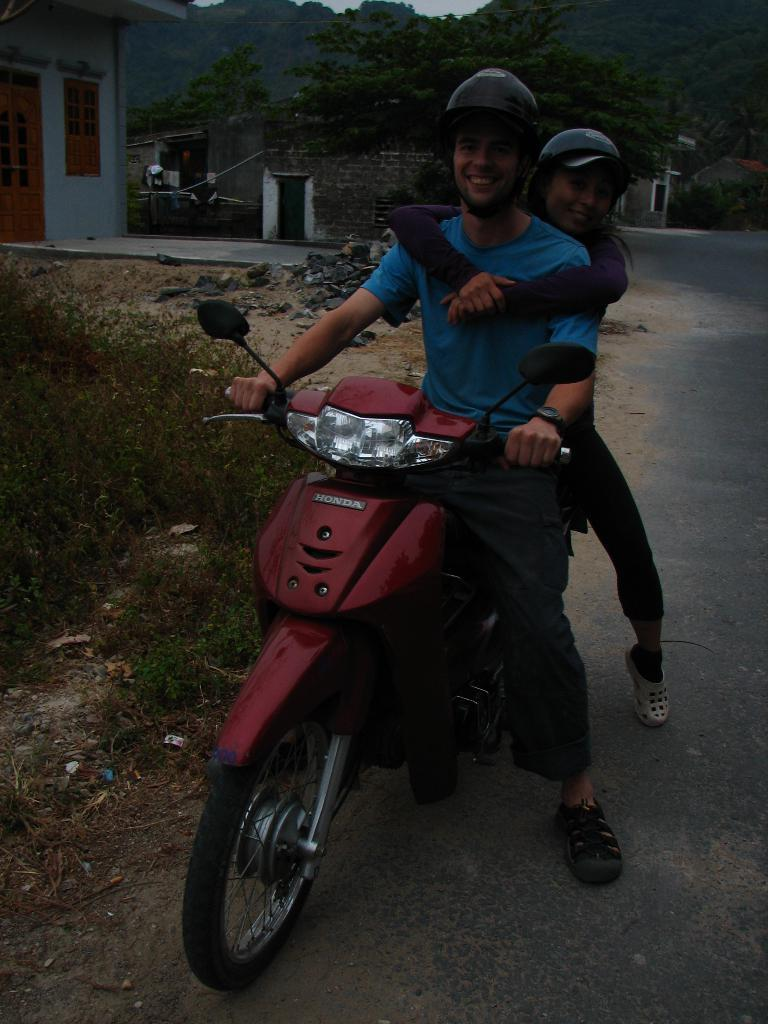How many people are in the image? There is a man and a lady in the image, making a total of two people. What are the man and lady doing in the image? Both the man and lady are on a vehicle. What type of vegetation can be seen in the image? There are plants and trees visible in the image. What type of structure is present in the image? There is a house in the image. What type of ground surface is visible in the image? There are stones and grass on the floor in the image. What type of yak can be seen in the image? There is no yak present in the image. What type of umbrella is being used by the man and lady in the image? There is no umbrella visible in the image. 